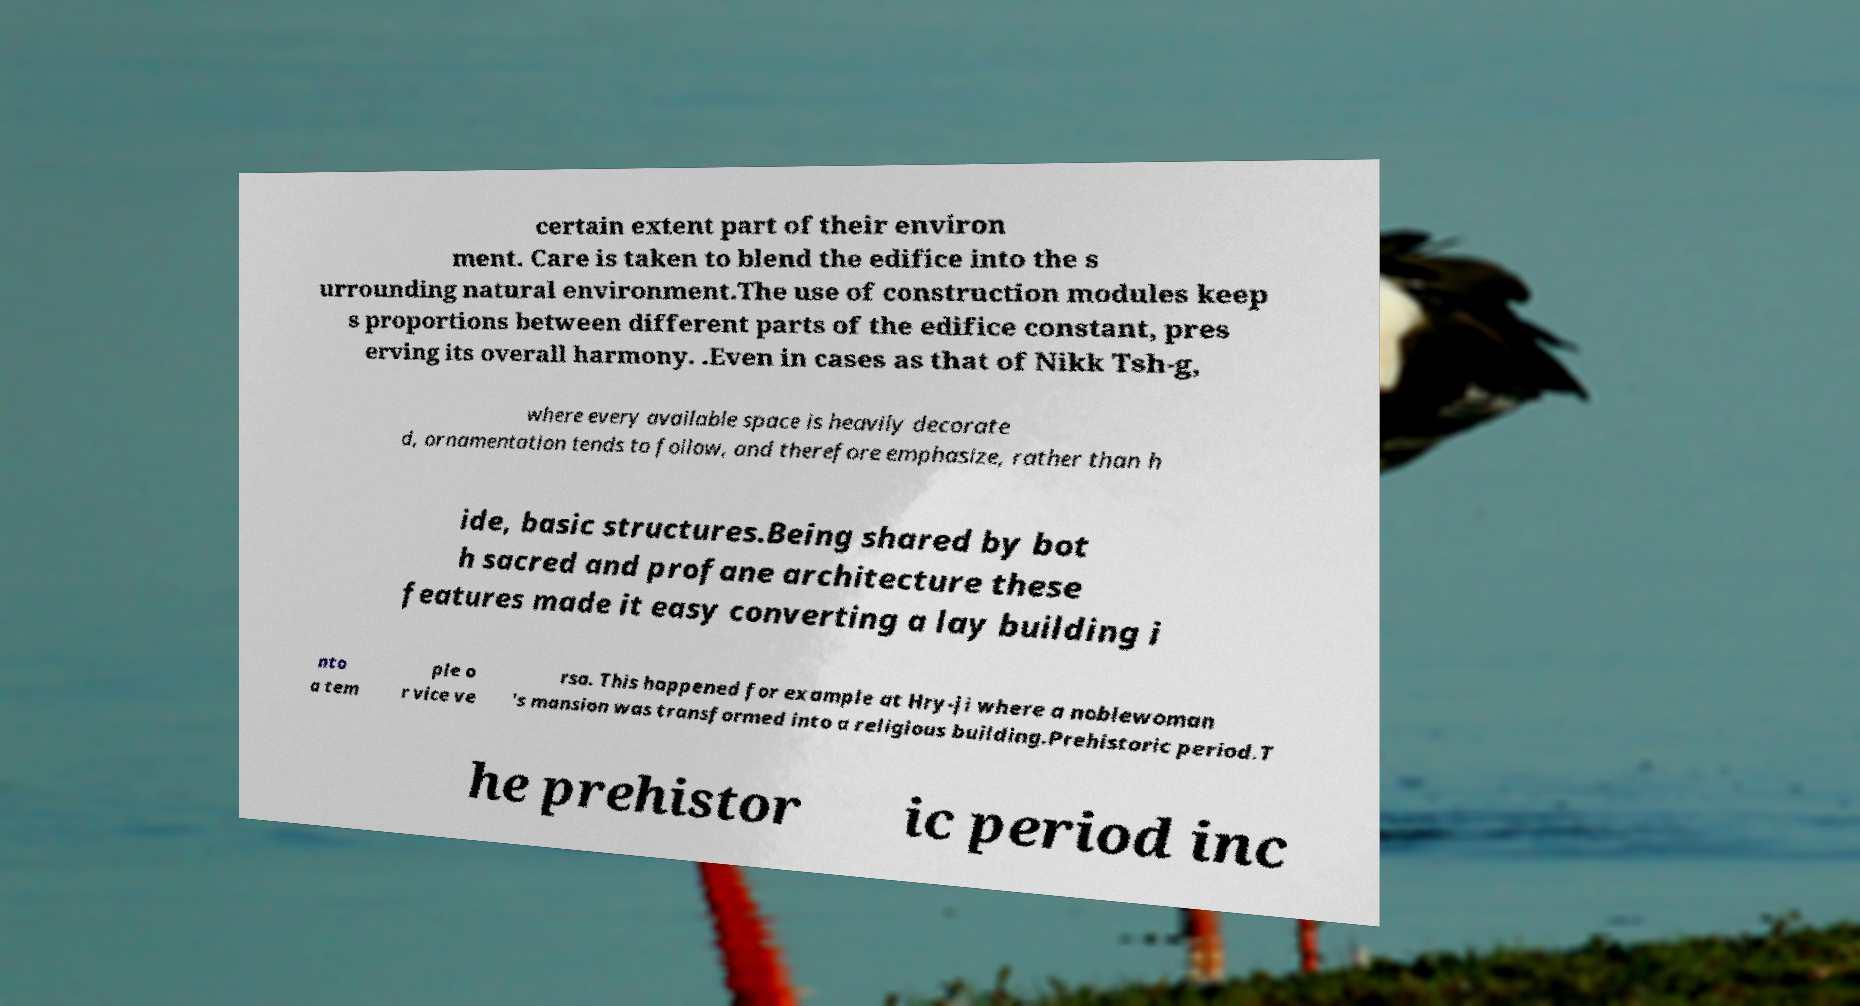Could you extract and type out the text from this image? certain extent part of their environ ment. Care is taken to blend the edifice into the s urrounding natural environment.The use of construction modules keep s proportions between different parts of the edifice constant, pres erving its overall harmony. .Even in cases as that of Nikk Tsh-g, where every available space is heavily decorate d, ornamentation tends to follow, and therefore emphasize, rather than h ide, basic structures.Being shared by bot h sacred and profane architecture these features made it easy converting a lay building i nto a tem ple o r vice ve rsa. This happened for example at Hry-ji where a noblewoman 's mansion was transformed into a religious building.Prehistoric period.T he prehistor ic period inc 